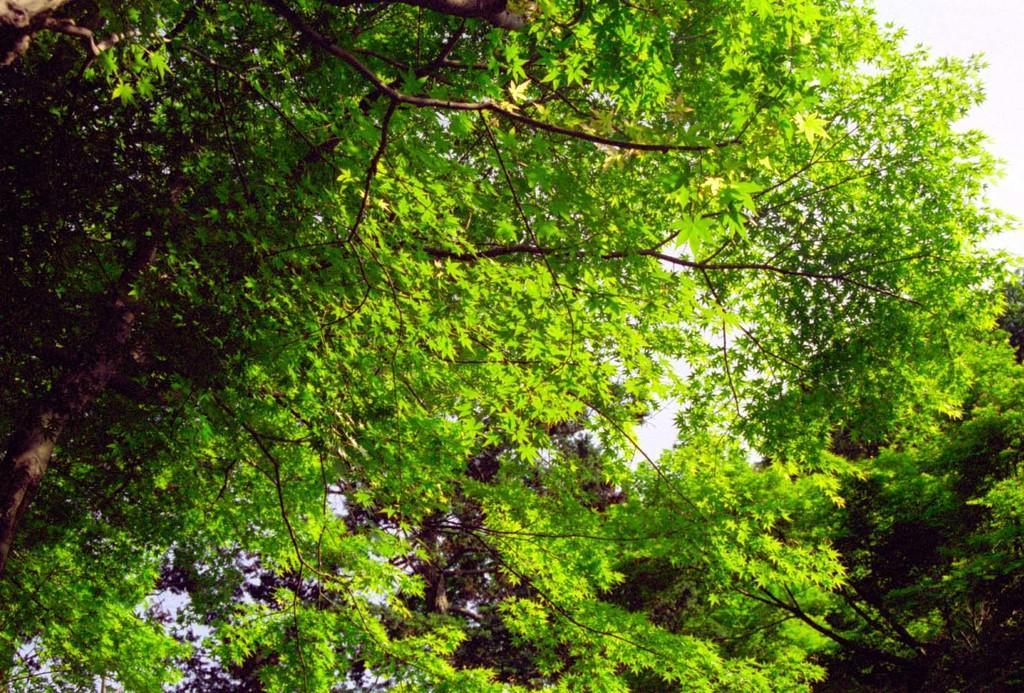Could you give a brief overview of what you see in this image? In the image we can see trees and the white sky. 